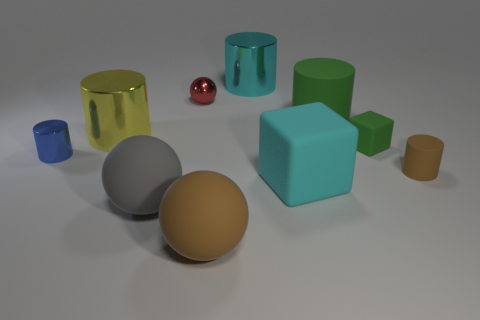Could you guess the material the objects may be made of? Based on their appearance, the objects could be made of various materials such as plastic, rubber, or metal, but without additional information, it's hard to determine their exact composition. 